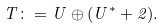Convert formula to latex. <formula><loc_0><loc_0><loc_500><loc_500>T \colon = U \oplus ( U ^ { \ast } + 2 ) .</formula> 